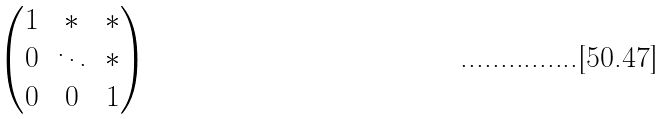<formula> <loc_0><loc_0><loc_500><loc_500>\begin{pmatrix} 1 & * & * \\ 0 & \ddots & * \\ 0 & 0 & 1 \end{pmatrix}</formula> 